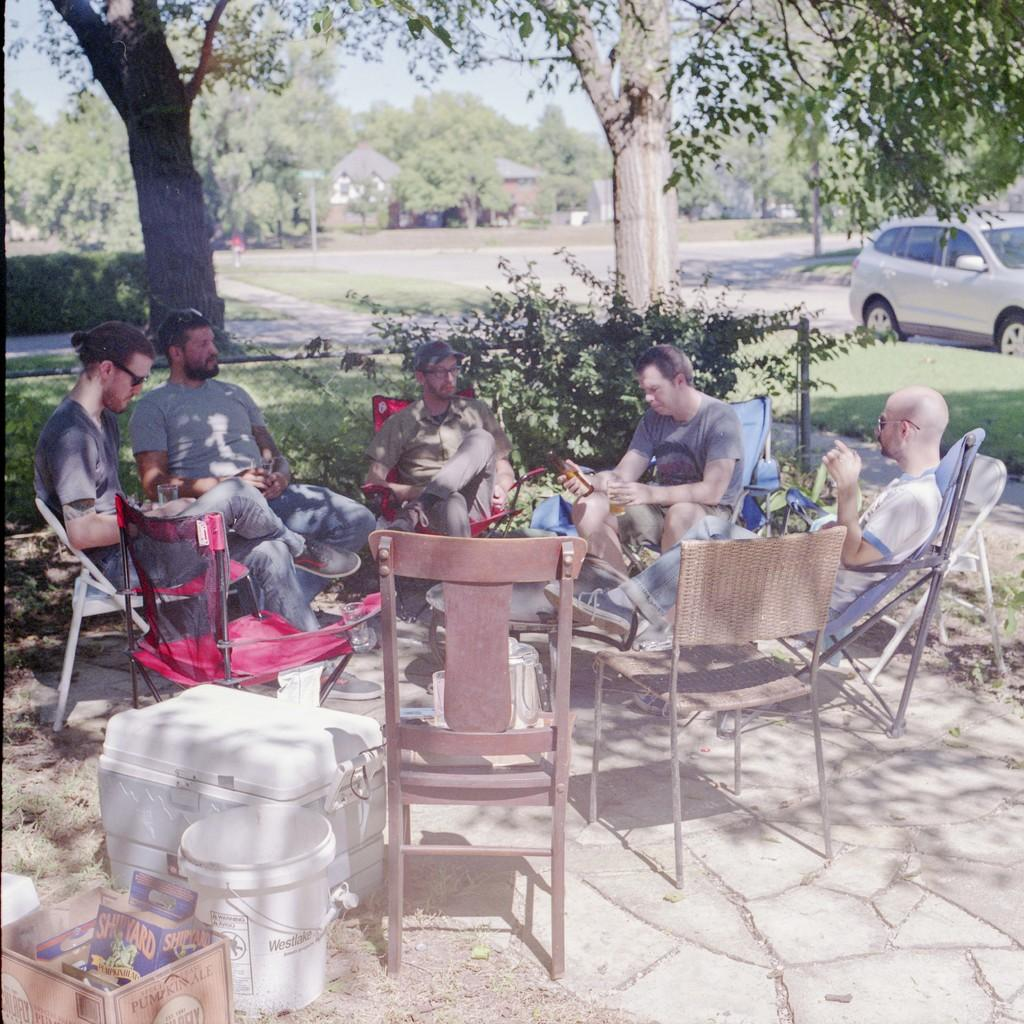What are the people in the image doing? There is a group of people sitting in the image. What objects are in front of the group of people? There is a basket and a bucket in front of the group of people. What can be seen in the background of the image? There is a car, trees, and the sky visible in the background of the image. What type of science experiment is being conducted by the cat in the image? There is no cat present in the image, and therefore no science experiment can be observed. 